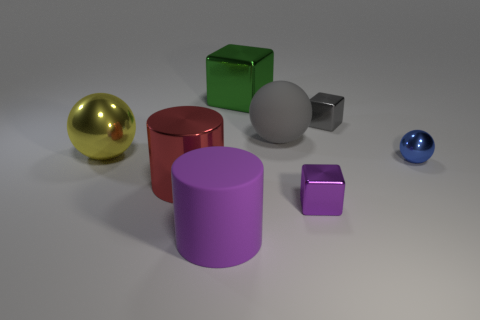How many purple matte cylinders are the same size as the gray sphere?
Provide a short and direct response. 1. Is the size of the shiny ball left of the blue metallic ball the same as the tiny gray object?
Offer a very short reply. No. There is a large metal object that is both in front of the large green cube and on the right side of the large metallic ball; what shape is it?
Keep it short and to the point. Cylinder. Are there any metal balls in front of the purple block?
Your answer should be compact. No. Is there anything else that is the same shape as the large gray matte object?
Offer a terse response. Yes. Do the purple metallic object and the green metallic thing have the same shape?
Offer a terse response. Yes. Is the number of gray matte objects that are in front of the small purple cube the same as the number of big things behind the green metal object?
Make the answer very short. Yes. What number of other things are there of the same material as the green thing
Provide a short and direct response. 5. How many large things are green things or yellow objects?
Your answer should be compact. 2. Are there an equal number of gray matte spheres that are behind the small blue ball and large red cylinders?
Offer a terse response. Yes. 